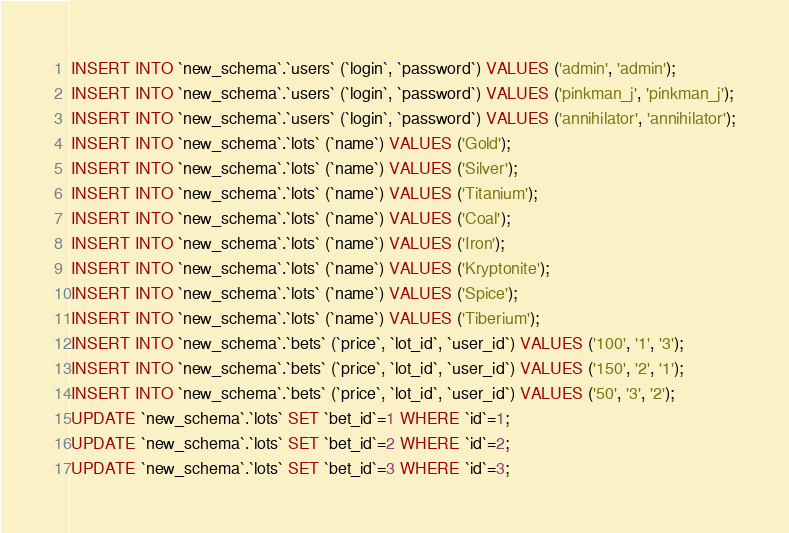<code> <loc_0><loc_0><loc_500><loc_500><_SQL_>INSERT INTO `new_schema`.`users` (`login`, `password`) VALUES ('admin', 'admin');
INSERT INTO `new_schema`.`users` (`login`, `password`) VALUES ('pinkman_j', 'pinkman_j');
INSERT INTO `new_schema`.`users` (`login`, `password`) VALUES ('annihilator', 'annihilator');
INSERT INTO `new_schema`.`lots` (`name`) VALUES ('Gold');
INSERT INTO `new_schema`.`lots` (`name`) VALUES ('Silver');
INSERT INTO `new_schema`.`lots` (`name`) VALUES ('Titanium');
INSERT INTO `new_schema`.`lots` (`name`) VALUES ('Coal');
INSERT INTO `new_schema`.`lots` (`name`) VALUES ('Iron');
INSERT INTO `new_schema`.`lots` (`name`) VALUES ('Kryptonite');
INSERT INTO `new_schema`.`lots` (`name`) VALUES ('Spice');
INSERT INTO `new_schema`.`lots` (`name`) VALUES ('Tiberium');
INSERT INTO `new_schema`.`bets` (`price`, `lot_id`, `user_id`) VALUES ('100', '1', '3');
INSERT INTO `new_schema`.`bets` (`price`, `lot_id`, `user_id`) VALUES ('150', '2', '1');
INSERT INTO `new_schema`.`bets` (`price`, `lot_id`, `user_id`) VALUES ('50', '3', '2');
UPDATE `new_schema`.`lots` SET `bet_id`=1 WHERE `id`=1;
UPDATE `new_schema`.`lots` SET `bet_id`=2 WHERE `id`=2;
UPDATE `new_schema`.`lots` SET `bet_id`=3 WHERE `id`=3;
</code> 